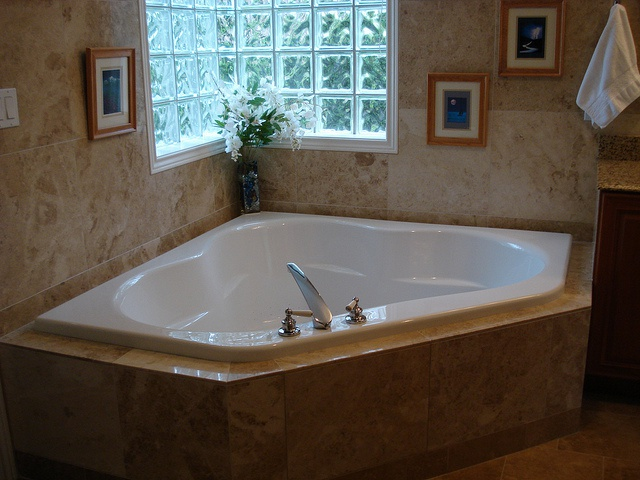Describe the objects in this image and their specific colors. I can see potted plant in black, lightblue, darkgray, and gray tones and vase in black and gray tones in this image. 